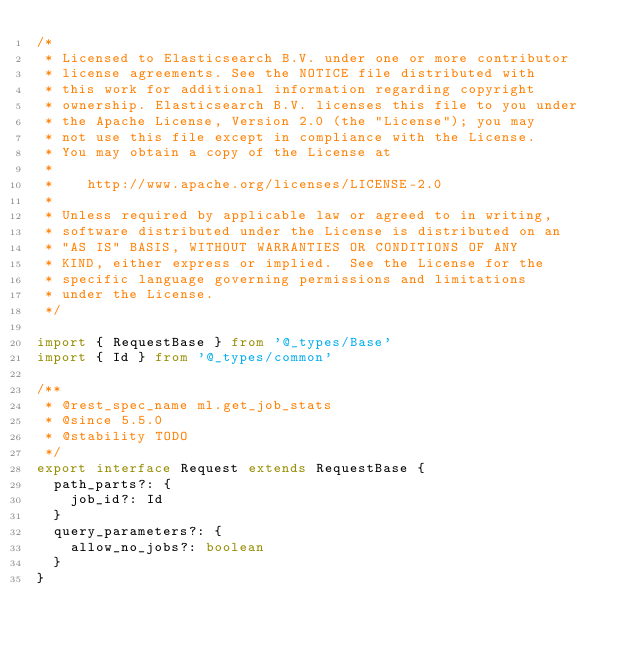Convert code to text. <code><loc_0><loc_0><loc_500><loc_500><_TypeScript_>/*
 * Licensed to Elasticsearch B.V. under one or more contributor
 * license agreements. See the NOTICE file distributed with
 * this work for additional information regarding copyright
 * ownership. Elasticsearch B.V. licenses this file to you under
 * the Apache License, Version 2.0 (the "License"); you may
 * not use this file except in compliance with the License.
 * You may obtain a copy of the License at
 *
 *    http://www.apache.org/licenses/LICENSE-2.0
 *
 * Unless required by applicable law or agreed to in writing,
 * software distributed under the License is distributed on an
 * "AS IS" BASIS, WITHOUT WARRANTIES OR CONDITIONS OF ANY
 * KIND, either express or implied.  See the License for the
 * specific language governing permissions and limitations
 * under the License.
 */

import { RequestBase } from '@_types/Base'
import { Id } from '@_types/common'

/**
 * @rest_spec_name ml.get_job_stats
 * @since 5.5.0
 * @stability TODO
 */
export interface Request extends RequestBase {
  path_parts?: {
    job_id?: Id
  }
  query_parameters?: {
    allow_no_jobs?: boolean
  }
}
</code> 